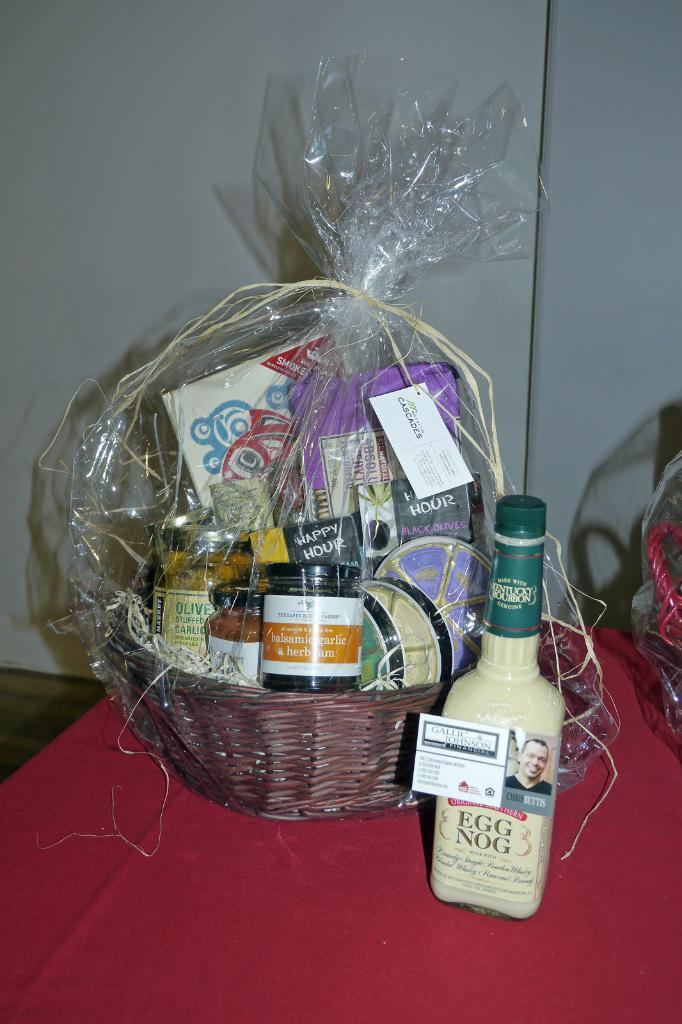<image>
Render a clear and concise summary of the photo. A bottle of Original Southern egg nog is sitting on a table next to a gift basket full of food. 